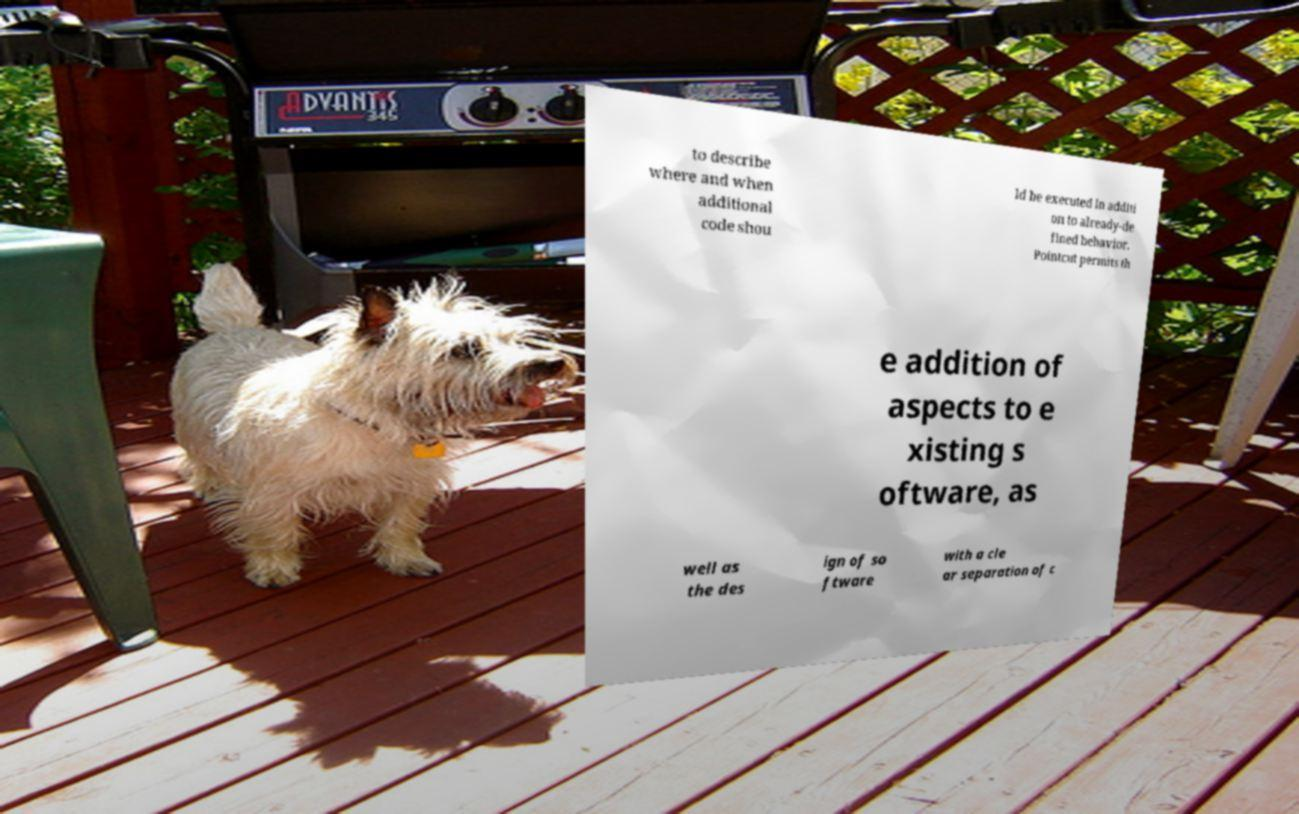Can you accurately transcribe the text from the provided image for me? to describe where and when additional code shou ld be executed in additi on to already-de fined behavior. Pointcut permits th e addition of aspects to e xisting s oftware, as well as the des ign of so ftware with a cle ar separation of c 